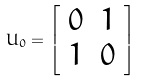<formula> <loc_0><loc_0><loc_500><loc_500>U _ { 0 } = { \left [ \begin{array} { l l } { 0 } & { 1 } \\ { 1 } & { 0 } \end{array} \right ] }</formula> 